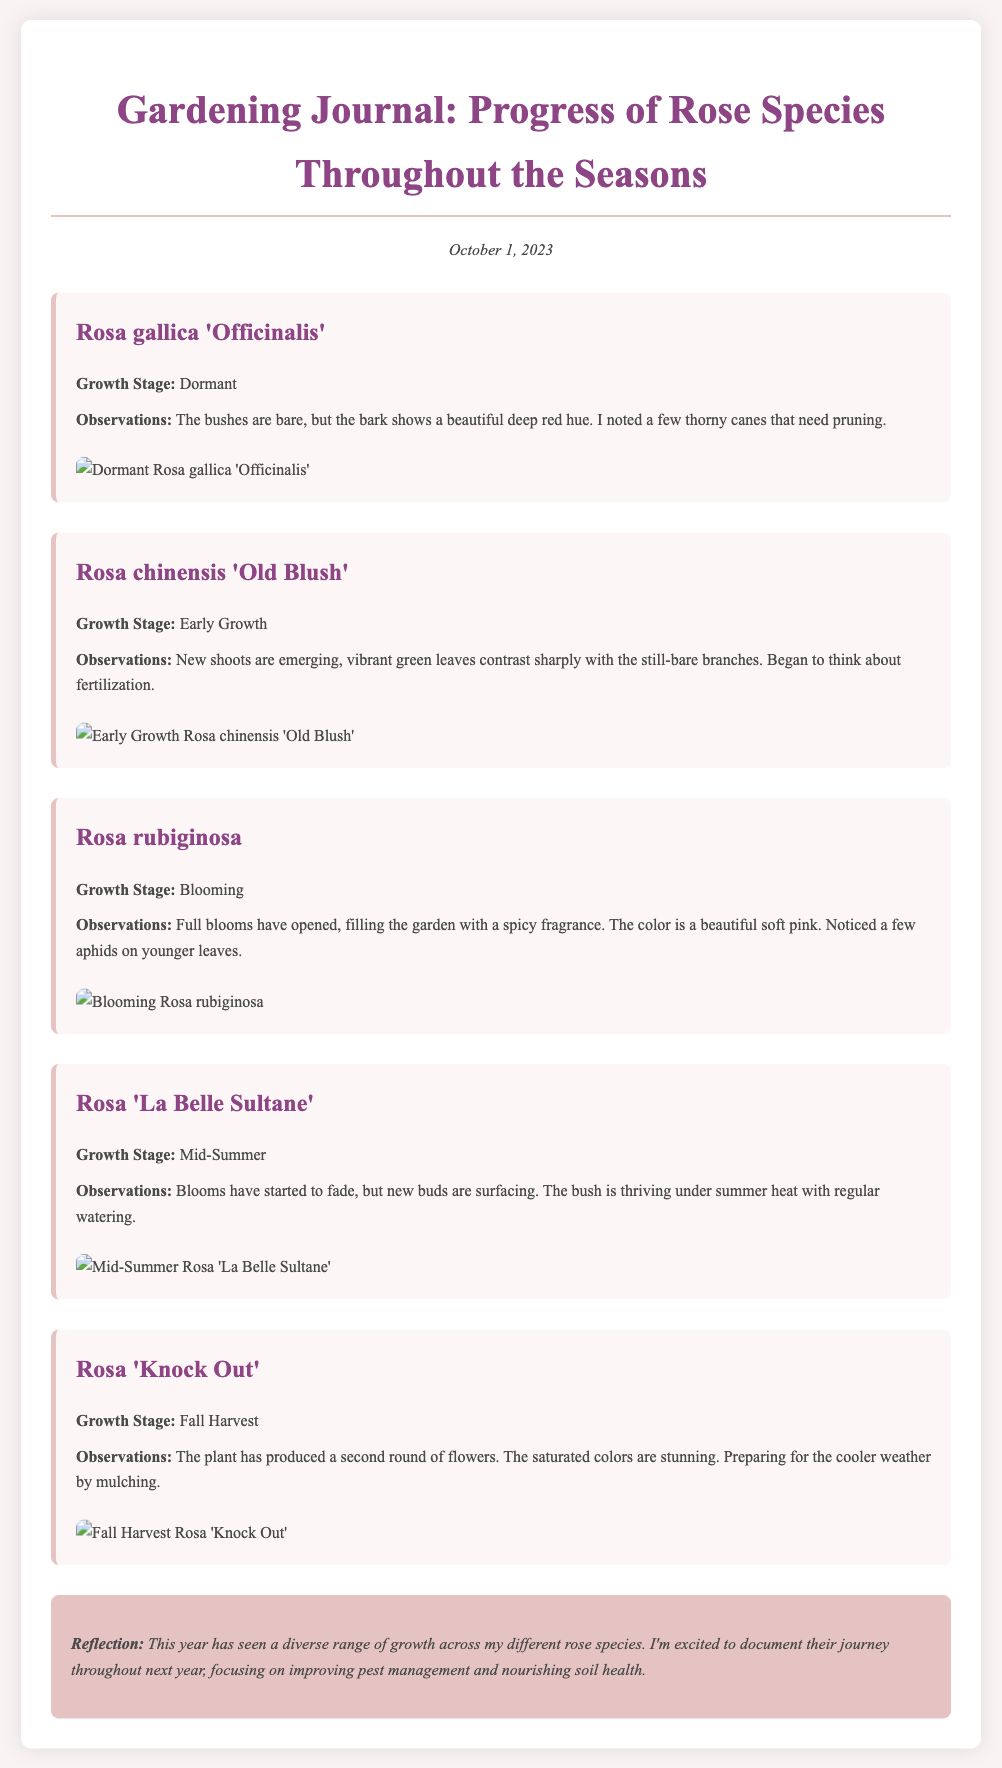What is the title of the document? The title is presented prominently at the top of the document in the header section.
Answer: Gardening Journal: Progress of Rose Species Throughout the Seasons What growth stage is Rosa gallica 'Officinalis' currently in? The growth stage is specified for each rose entry, showing their current condition.
Answer: Dormant How many rose species are documented in this journal entry? The document provides separate entries for each rose species, allowing for easy counting.
Answer: Five What is the observation for Rosa rubiginosa? Each entry includes observations that describe the state of the roses during their growth stages.
Answer: Full blooms have opened, filling the garden with a spicy fragrance What reflection does the author provide at the end? The reflection summarizes thoughts on the overall experience of growing the different rose species throughout the year.
Answer: This year has seen a diverse range of growth across my different rose species 